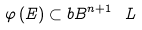<formula> <loc_0><loc_0><loc_500><loc_500>\varphi \left ( E \right ) \subset b B ^ { n + 1 } \ L</formula> 